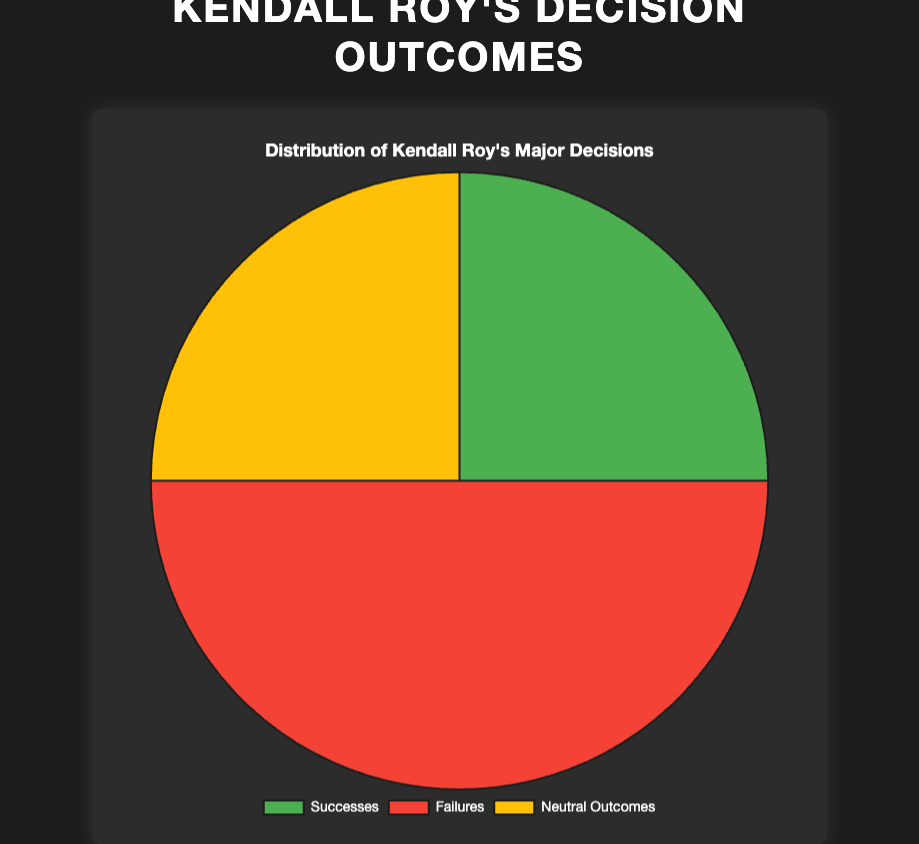What percentage of Kendall Roy's major decisions were failures? The chart indicates the number of failures as 12. To find the percentage, divide the number of failures (12) by the total number of decisions (6+12+6=24) and multiply by 100.
Answer: 50% How many more failures did Kendall have compared to his successes? The number of failures is 12, and the number of successes is 6. Subtract the number of successes from the number of failures.
Answer: 6 What portion of Kendall Roy's outcomes were neutral? The chart shows 6 neutral outcomes out of a total of 24 decisions. To get the portion, divide the number of neutral outcomes by the total decisions (6/24) and simplify.
Answer: 1/4 Which category of outcomes is largest in Kendall's decision-making? From the data represented in the pie chart, the largest segment corresponds to failures with 12 decisions. Compare the three categories visually.
Answer: Failures Between successes and neutral outcomes, which had a greater number, and by how much? Both successes and neutral outcomes have the same number, 6. Subtract to find the difference.
Answer: 0 (they are equal) What is the ratio of Kendall's failures to his total decisions? There are 12 failures and 24 total decisions. Therefore, the ratio of failures to total decisions is 12:24, which can be simplified.
Answer: 1:2 If Kendall had 2 more successes, what would the new percentage of failures be? Currently, there are 12 failures out of 24 decisions. With 2 more successes, the total decisions become 26 (24+2) while failures remain 12. Calculate the new percentage (12/26*100).
Answer: Approximately 46.15% What fraction of Kendall's decisions were neither successes nor neutral outcomes? Failures are 12 out of 24 decisions. Calculate the fraction of decisions that are failures.
Answer: 1/2 Which visual attribute on the chart indicates the neutral outcomes? The color for neutral outcomes in the pie chart is yellow. Identify the segment based on the color indications.
Answer: Yellow 